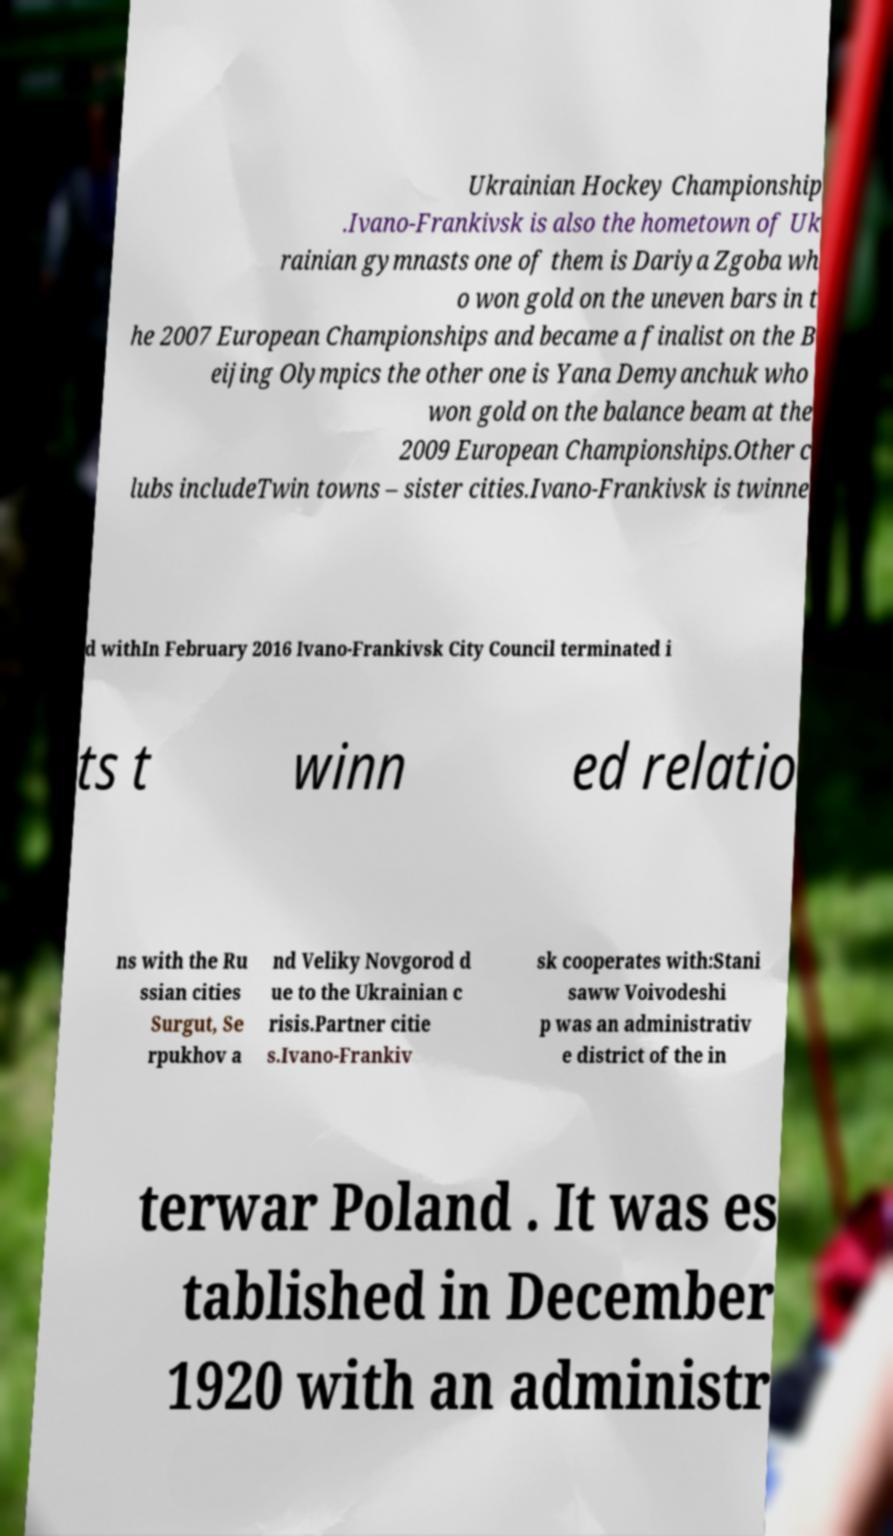For documentation purposes, I need the text within this image transcribed. Could you provide that? Ukrainian Hockey Championship .Ivano-Frankivsk is also the hometown of Uk rainian gymnasts one of them is Dariya Zgoba wh o won gold on the uneven bars in t he 2007 European Championships and became a finalist on the B eijing Olympics the other one is Yana Demyanchuk who won gold on the balance beam at the 2009 European Championships.Other c lubs includeTwin towns – sister cities.Ivano-Frankivsk is twinne d withIn February 2016 Ivano-Frankivsk City Council terminated i ts t winn ed relatio ns with the Ru ssian cities Surgut, Se rpukhov a nd Veliky Novgorod d ue to the Ukrainian c risis.Partner citie s.Ivano-Frankiv sk cooperates with:Stani saww Voivodeshi p was an administrativ e district of the in terwar Poland . It was es tablished in December 1920 with an administr 